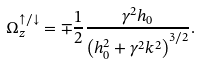<formula> <loc_0><loc_0><loc_500><loc_500>\Omega _ { z } ^ { \uparrow / \downarrow } = \mp \frac { 1 } { 2 } \frac { \gamma ^ { 2 } h _ { 0 } } { { \left ( { h _ { 0 } ^ { 2 } + \gamma ^ { 2 } k ^ { 2 } } \right ) ^ { 3 / 2 } } } .</formula> 